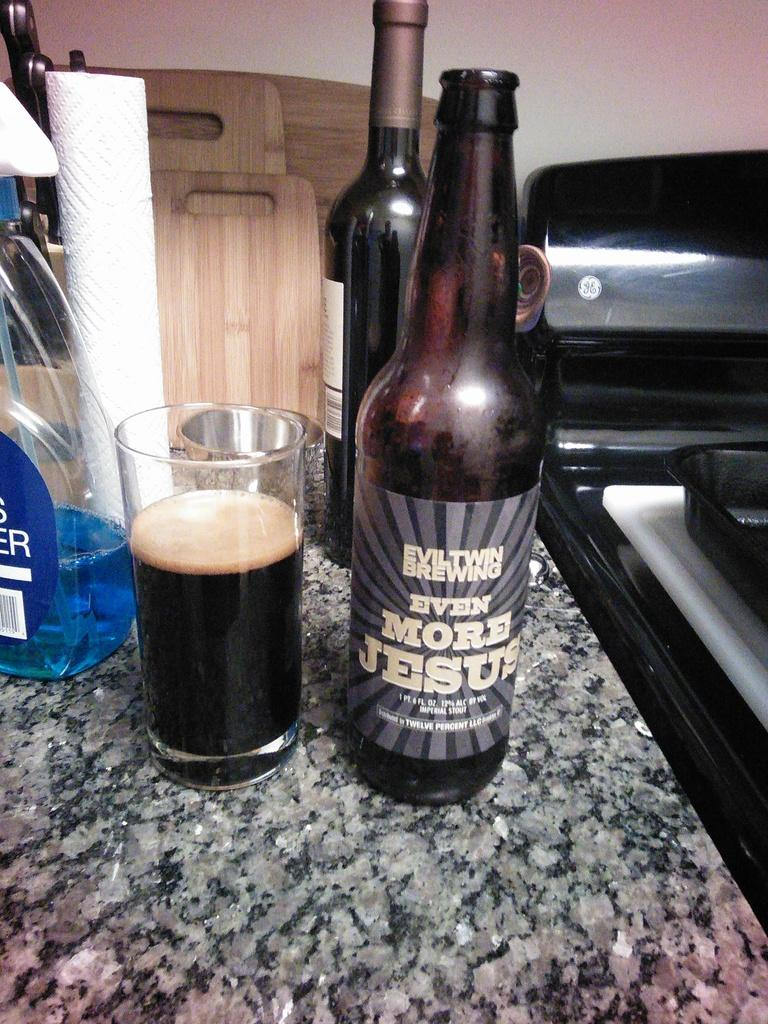<image>
Describe the image concisely. An open bottle of Even More Jesus stout by a nearly full glass. 